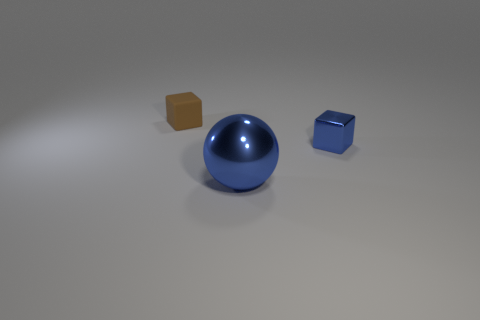Add 2 big brown matte cylinders. How many objects exist? 5 Subtract all spheres. How many objects are left? 2 Subtract 1 blue spheres. How many objects are left? 2 Subtract all yellow metal blocks. Subtract all blue metallic things. How many objects are left? 1 Add 2 blue cubes. How many blue cubes are left? 3 Add 1 shiny cubes. How many shiny cubes exist? 2 